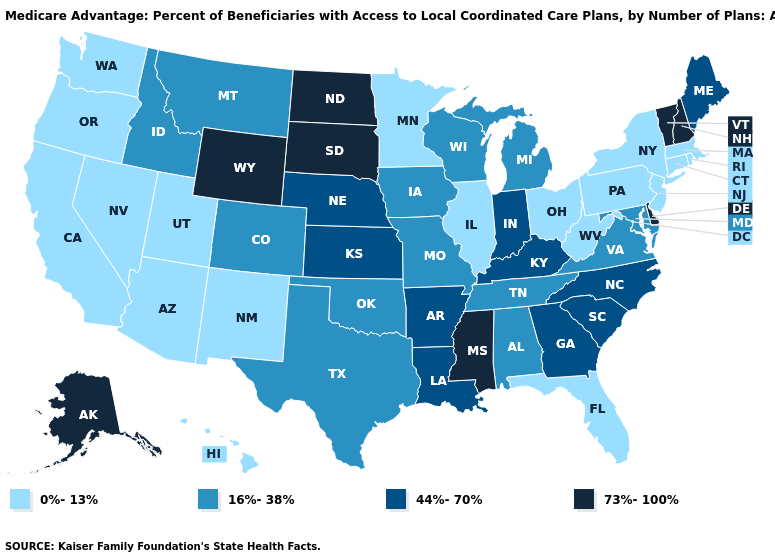Does Kentucky have a lower value than New Jersey?
Concise answer only. No. Among the states that border Minnesota , does North Dakota have the lowest value?
Quick response, please. No. What is the lowest value in the USA?
Be succinct. 0%-13%. Name the states that have a value in the range 73%-100%?
Write a very short answer. Alaska, Delaware, Mississippi, North Dakota, New Hampshire, South Dakota, Vermont, Wyoming. What is the value of Connecticut?
Be succinct. 0%-13%. Among the states that border New Jersey , does Delaware have the lowest value?
Give a very brief answer. No. Which states have the highest value in the USA?
Short answer required. Alaska, Delaware, Mississippi, North Dakota, New Hampshire, South Dakota, Vermont, Wyoming. Name the states that have a value in the range 44%-70%?
Quick response, please. Arkansas, Georgia, Indiana, Kansas, Kentucky, Louisiana, Maine, North Carolina, Nebraska, South Carolina. Does Alabama have a higher value than New Jersey?
Short answer required. Yes. Name the states that have a value in the range 44%-70%?
Quick response, please. Arkansas, Georgia, Indiana, Kansas, Kentucky, Louisiana, Maine, North Carolina, Nebraska, South Carolina. What is the value of Massachusetts?
Concise answer only. 0%-13%. Does Arkansas have the lowest value in the USA?
Quick response, please. No. Name the states that have a value in the range 44%-70%?
Write a very short answer. Arkansas, Georgia, Indiana, Kansas, Kentucky, Louisiana, Maine, North Carolina, Nebraska, South Carolina. Which states have the lowest value in the South?
Short answer required. Florida, West Virginia. How many symbols are there in the legend?
Short answer required. 4. 